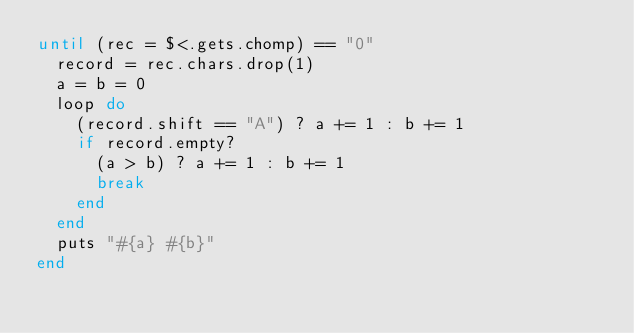<code> <loc_0><loc_0><loc_500><loc_500><_Ruby_>until (rec = $<.gets.chomp) == "0"
  record = rec.chars.drop(1)
  a = b = 0
  loop do
    (record.shift == "A") ? a += 1 : b += 1
    if record.empty?
      (a > b) ? a += 1 : b += 1
      break
    end
  end
  puts "#{a} #{b}"
end
</code> 